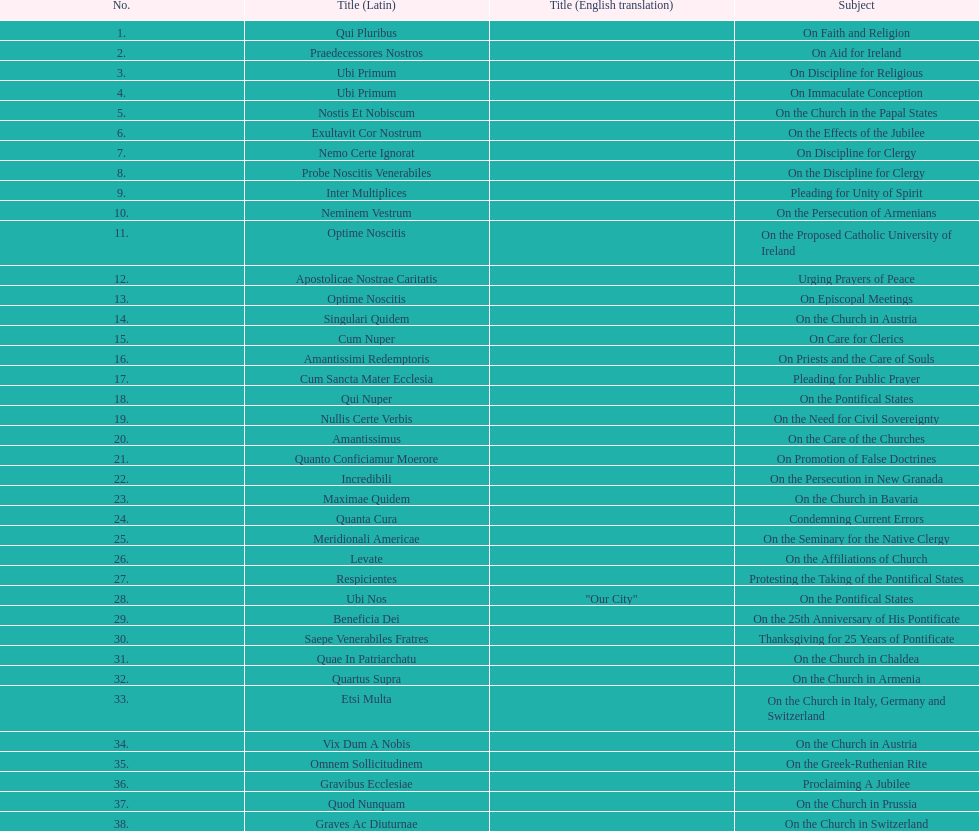Date of the last encyclical whose subject contained the word "pontificate" 5 August 1871. 